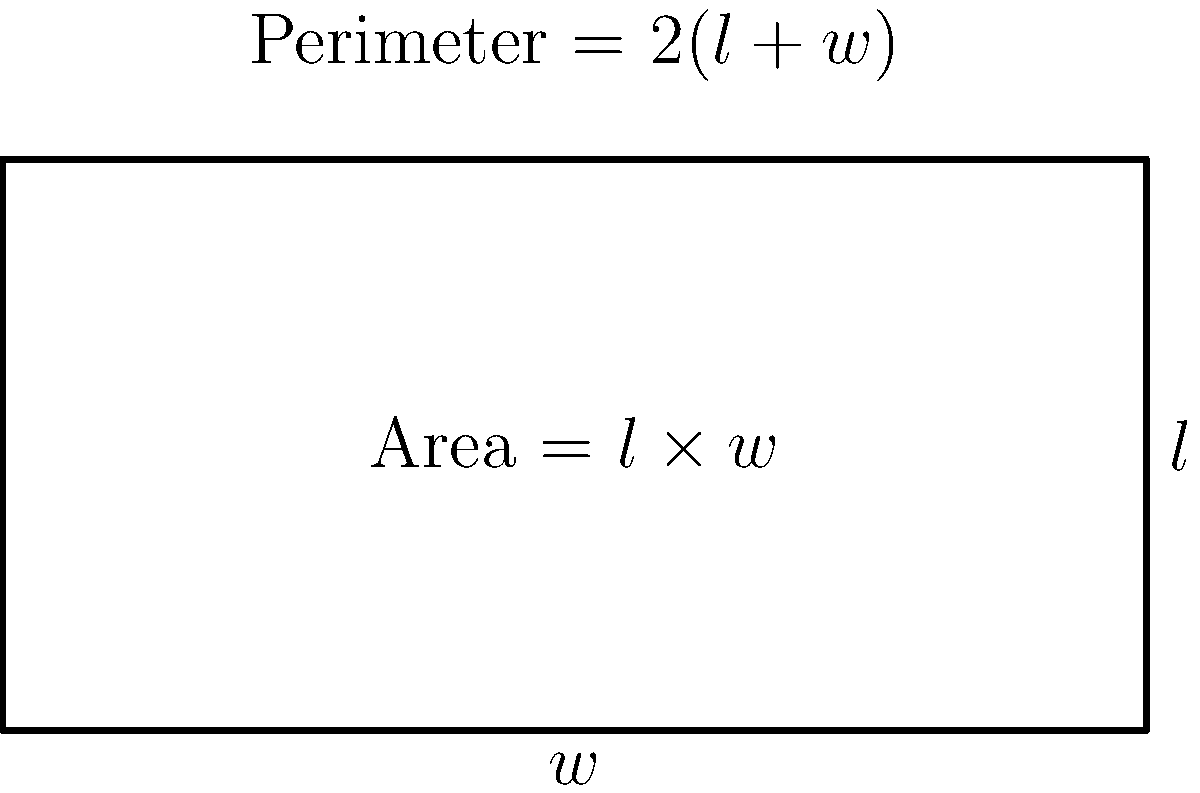An automated assembly line needs to be designed within a rectangular space. The total perimeter of the space is fixed at 300 meters. What dimensions (length and width) should the rectangular space have to maximize the area for the assembly line? To solve this problem, we'll follow these steps:

1) Let $l$ be the length and $w$ be the width of the rectangle.

2) Given that the perimeter is 300 meters, we can write:
   $$2l + 2w = 300$$
   $$l + w = 150$$

3) Express $l$ in terms of $w$:
   $$l = 150 - w$$

4) The area of the rectangle is given by $A = l \times w$. Substituting for $l$:
   $$A = (150 - w) \times w = 150w - w^2$$

5) To find the maximum area, we need to find where the derivative of $A$ with respect to $w$ is zero:
   $$\frac{dA}{dw} = 150 - 2w$$
   $$0 = 150 - 2w$$
   $$2w = 150$$
   $$w = 75$$

6) Since $w = 75$, we can find $l$:
   $$l = 150 - 75 = 75$$

7) To confirm this is a maximum (not a minimum), we can check the second derivative:
   $$\frac{d^2A}{dw^2} = -2$$
   This is negative, confirming we have found a maximum.

8) Therefore, the rectangle should be a square with both length and width equal to 75 meters.

This result aligns with the mathematical principle that, for a given perimeter, a square always has the largest area among all possible rectangles.
Answer: Length = 75 m, Width = 75 m 